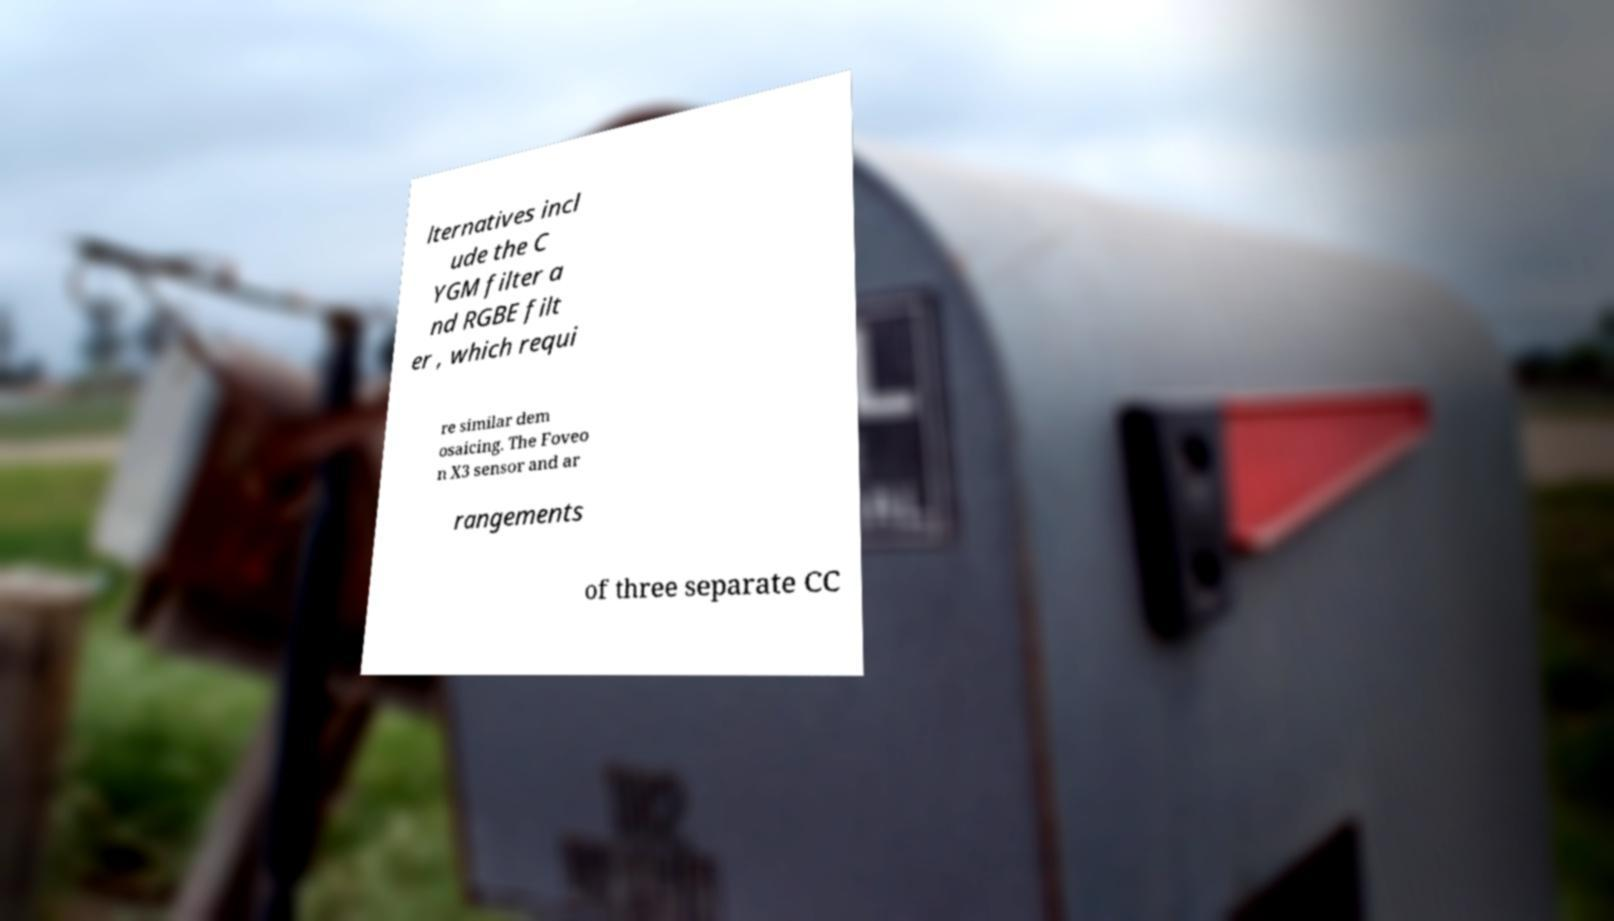There's text embedded in this image that I need extracted. Can you transcribe it verbatim? lternatives incl ude the C YGM filter a nd RGBE filt er , which requi re similar dem osaicing. The Foveo n X3 sensor and ar rangements of three separate CC 